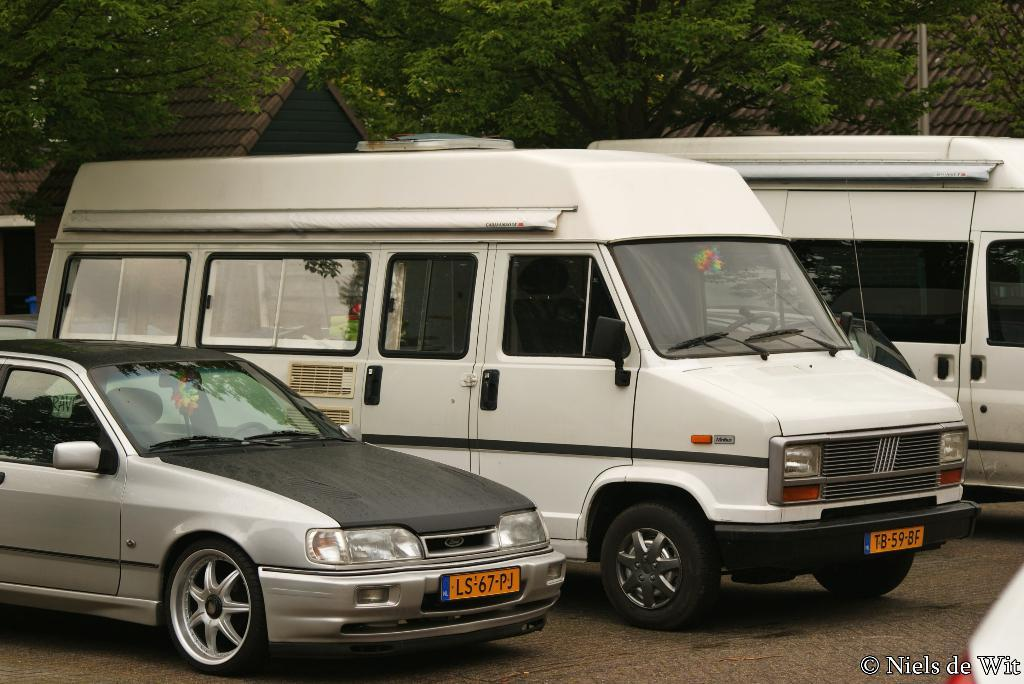<image>
Provide a brief description of the given image. A car with the license plate LS-67-PK is parked next to a white truck. 